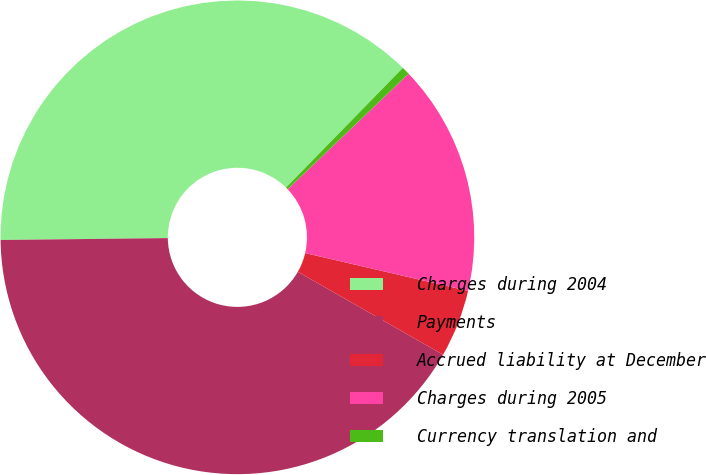Convert chart to OTSL. <chart><loc_0><loc_0><loc_500><loc_500><pie_chart><fcel>Charges during 2004<fcel>Payments<fcel>Accrued liability at December<fcel>Charges during 2005<fcel>Currency translation and<nl><fcel>37.49%<fcel>41.57%<fcel>4.62%<fcel>15.77%<fcel>0.55%<nl></chart> 